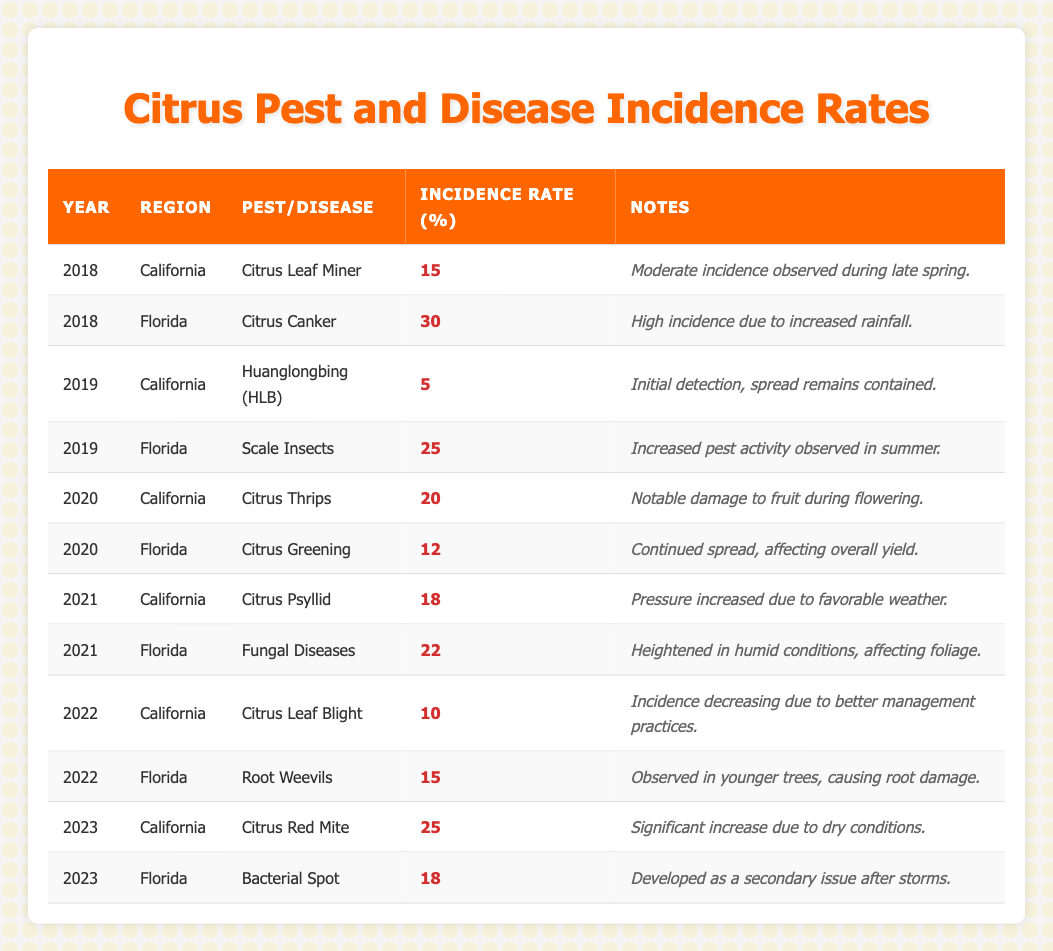What was the incidence rate of Citrus Canker in Florida in 2018? From the table, we can find the row for the year 2018 and region Florida. The corresponding pest/disease is Citrus Canker with an incidence rate of 30%
Answer: 30% Which pest disease had the highest incidence rate in Florida in 2021? In the table, looking at the year 2021 for Florida, the diseases are Fungal Diseases with an incidence rate of 22%. This is higher than any other disease listed for Florida in that year
Answer: Fungal Diseases What is the difference in incidence rates between Citrus Thrips in California (2020) and Citrus Greening in Florida (2020)? The incidence rate for Citrus Thrips in California in 2020 is 20% and for Citrus Greening in Florida it is 12%. To find the difference, we subtract 12 from 20, which gives us 8
Answer: 8 True or False: Citrus Leaf Blight incidence decreased in California from 2021 to 2022. In the table, we see that the incidence for Citrus Leaf Blight in California is not listed for 2021 and is 10% for 2022, so we cannot determine a decrease based on the data available for those years
Answer: True What are the average incidence rates of pests and diseases for California across all years listed in the table? For California, the incidence rates across years are: Citrus Leaf Miner (15%), Huanglongbing (5%), Citrus Thrips (20%), Citrus Psyllid (18%), Citrus Leaf Blight (10%), and Citrus Red Mite (25%). Adding these gives 15 + 5 + 20 + 18 + 10 + 25 = 93. There are 6 total incidences, so the average is 93/6 = 15.5
Answer: 15.5 Which pest disease in California had a significant increase due to dry conditions in 2023? In the table, it shows that in 2023, the incidence of Citrus Red Mite increased significantly due to dry conditions, which is indicated by the notes in the 2023 row for California. This disease had a reported incidence rate of 25%
Answer: Citrus Red Mite How many regions had an incidence rate of 18% in 2023? By checking the table for 2023, in California, the incidence rate is 25% for Citrus Red Mite, and in Florida, it is 18% for Bacterial Spot. Therefore, there is 1 region (Florida) with an incidence rate of 18%
Answer: 1 What was the overall trend of pest and disease incidence in California from 2018 to 2022? By analyzing the respective incidence rates for California from 2018 (15%) to 2022 (10%), we find that the rates fluctuate but overall show a decreasing trend from an initial moderate incidence to a lower incidence of Citrus Leaf Blight in 2022. It can be concluded that better management practices contributed to this decrease
Answer: Decreasing trend What was the incidence rate for Scale Insects in Florida in 2019? In the table, the entry for Florida in 2019 clearly states that the incidence rate for Scale Insects is 25%
Answer: 25% 